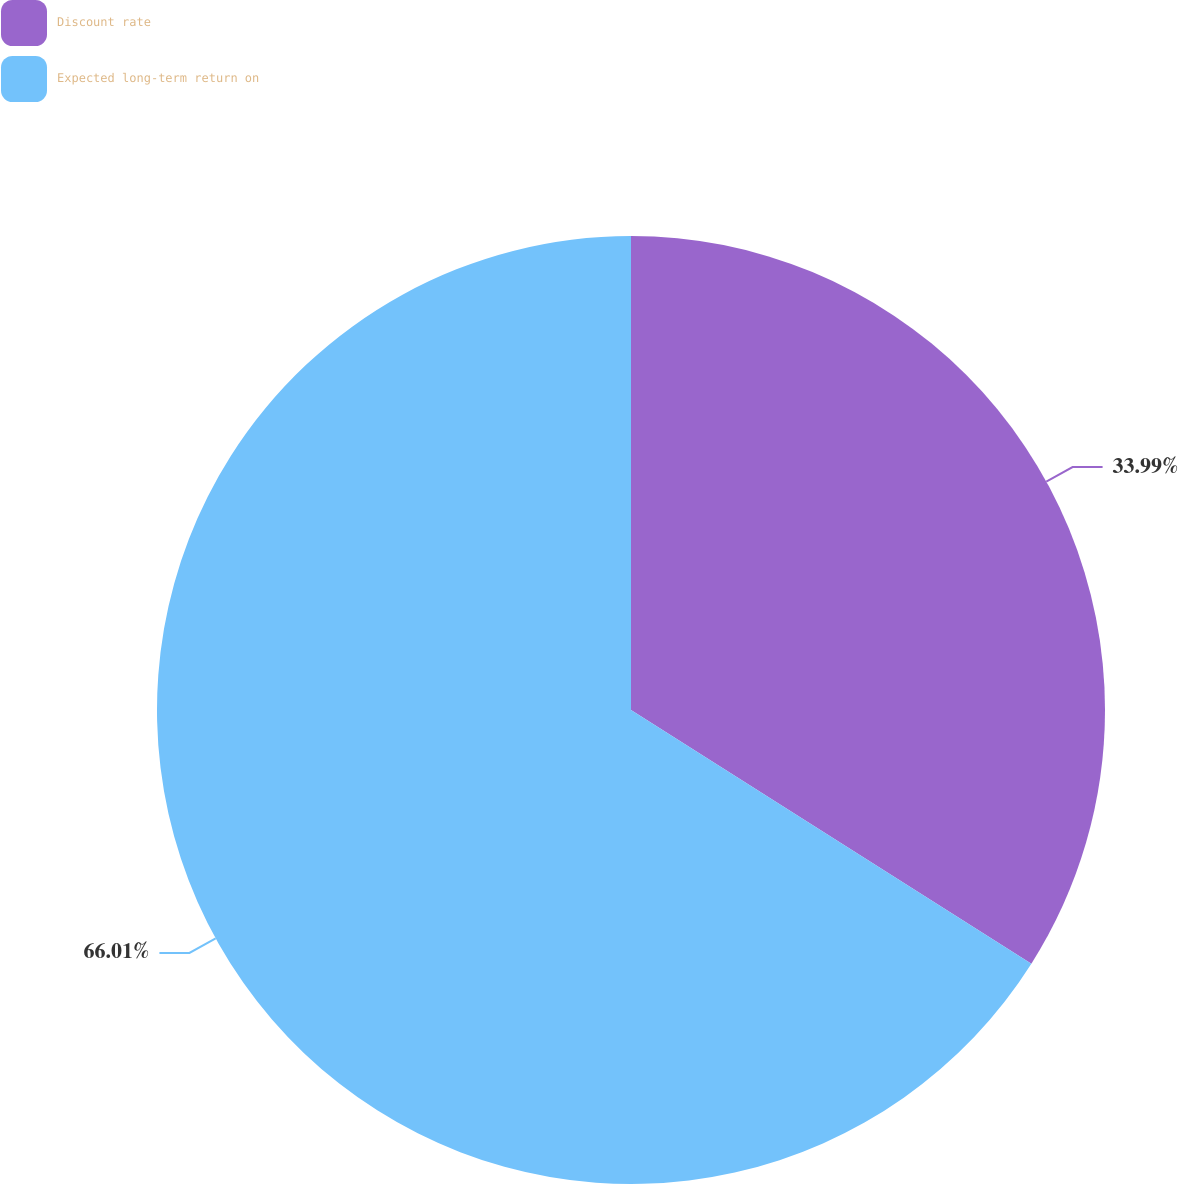Convert chart to OTSL. <chart><loc_0><loc_0><loc_500><loc_500><pie_chart><fcel>Discount rate<fcel>Expected long-term return on<nl><fcel>33.99%<fcel>66.01%<nl></chart> 